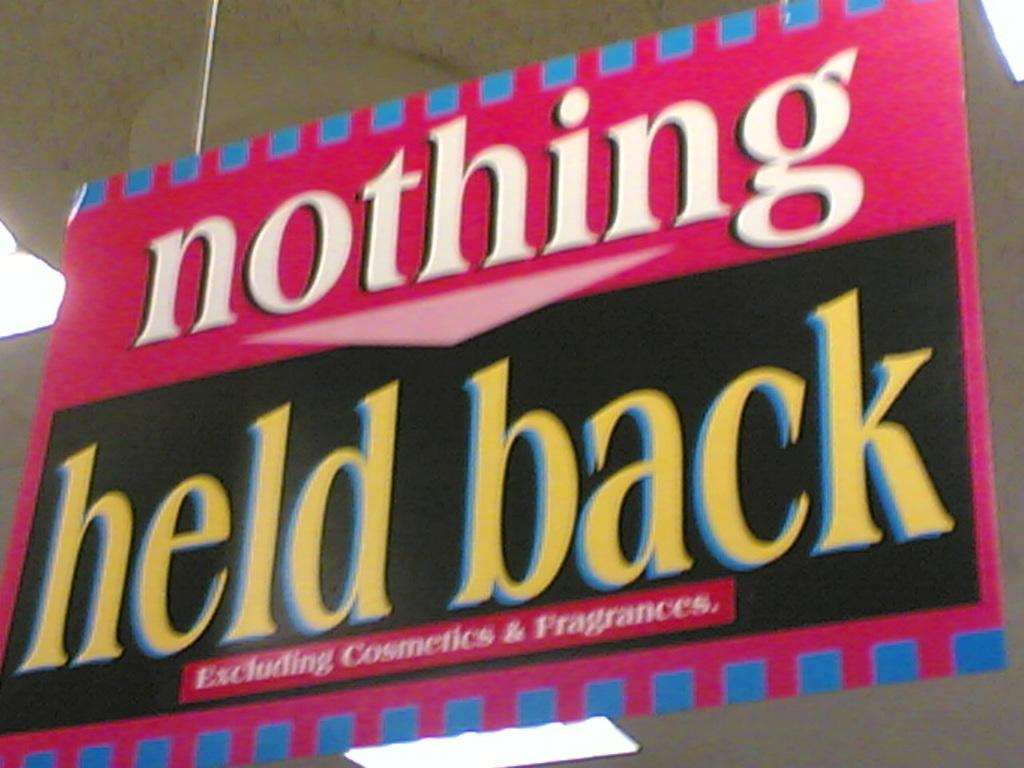What is held back?
Offer a terse response. Nothing. What is excluded in the sign?
Give a very brief answer. Cosmetics & fragrances. 